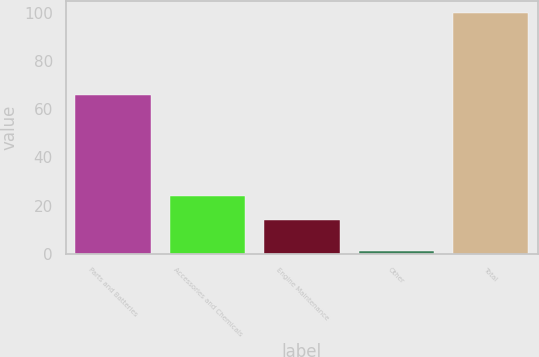<chart> <loc_0><loc_0><loc_500><loc_500><bar_chart><fcel>Parts and Batteries<fcel>Accessories and Chemicals<fcel>Engine Maintenance<fcel>Other<fcel>Total<nl><fcel>66<fcel>23.9<fcel>14<fcel>1<fcel>100<nl></chart> 